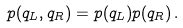<formula> <loc_0><loc_0><loc_500><loc_500>p ( q _ { L } , q _ { R } ) = p ( q _ { L } ) p ( q _ { R } ) \, .</formula> 